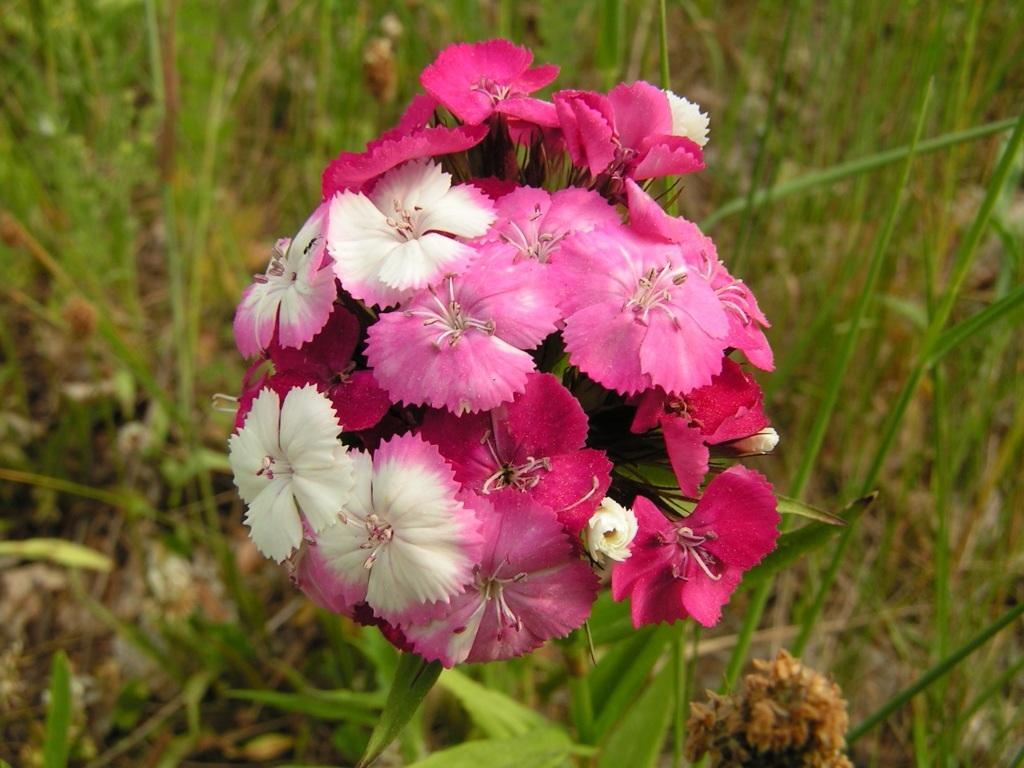What is the main subject of the image? The main subject of the image is a bunch of leaves. Can you describe the background of the image? Leaves are present in the background of the image. What type of polish is being applied to the leaves in the image? There is no polish being applied to the leaves in the image; it is a still image of a bunch of leaves. 